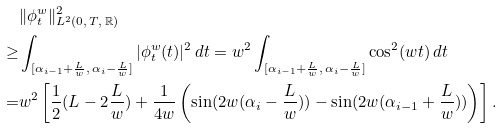Convert formula to latex. <formula><loc_0><loc_0><loc_500><loc_500>& \| \phi _ { t } ^ { w } \| _ { L ^ { 2 } ( 0 , \, T , \, \mathbb { R } ) } ^ { 2 } \\ \geq & \int _ { [ \alpha _ { i - 1 } + \frac { L } { w } , \, \alpha _ { i } - \frac { L } { w } ] } | \phi _ { t } ^ { w } ( t ) | ^ { 2 } \, d t = w ^ { 2 } \int _ { [ \alpha _ { i - 1 } + \frac { L } { w } , \, \alpha _ { i } - \frac { L } { w } ] } \cos ^ { 2 } ( w t ) \, d t \\ = & w ^ { 2 } \left [ \frac { 1 } { 2 } ( L - 2 \frac { L } { w } ) + \frac { 1 } { 4 w } \left ( \sin ( 2 w ( \alpha _ { i } - \frac { L } { w } ) ) - \sin ( 2 w ( \alpha _ { i - 1 } + \frac { L } { w } ) ) \right ) \right ] .</formula> 